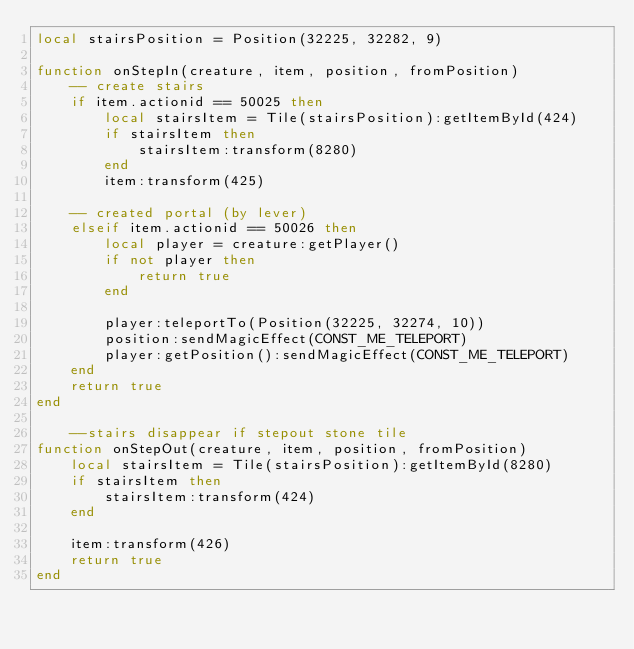<code> <loc_0><loc_0><loc_500><loc_500><_Lua_>local stairsPosition = Position(32225, 32282, 9)

function onStepIn(creature, item, position, fromPosition)
	-- create stairs
	if item.actionid == 50025 then
		local stairsItem = Tile(stairsPosition):getItemById(424)
		if stairsItem then
			stairsItem:transform(8280)
		end
		item:transform(425)

	-- created portal (by lever)
	elseif item.actionid == 50026 then
		local player = creature:getPlayer()
		if not player then
			return true
		end

		player:teleportTo(Position(32225, 32274, 10))
		position:sendMagicEffect(CONST_ME_TELEPORT)
		player:getPosition():sendMagicEffect(CONST_ME_TELEPORT)
	end
	return true
end

	--stairs disappear if stepout stone tile
function onStepOut(creature, item, position, fromPosition)
	local stairsItem = Tile(stairsPosition):getItemById(8280)
	if stairsItem then
		stairsItem:transform(424)
	end

	item:transform(426)
	return true
end</code> 